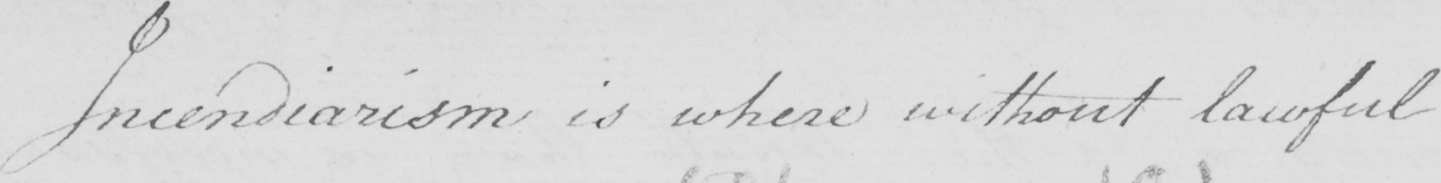Can you read and transcribe this handwriting? Incendiarism is where without lawful 